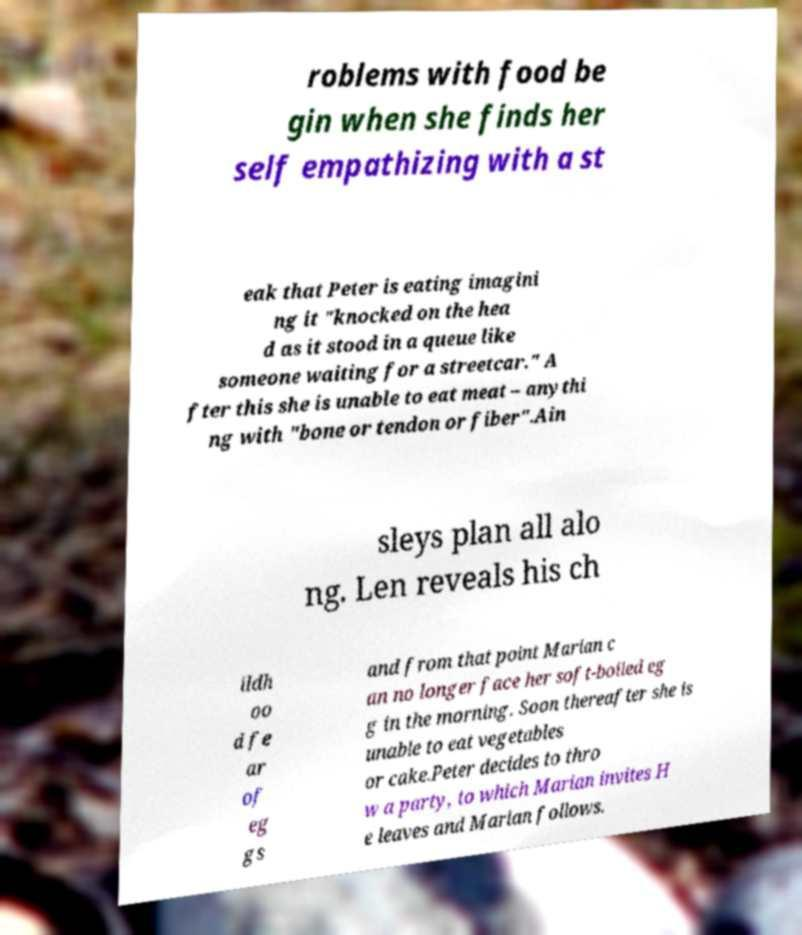For documentation purposes, I need the text within this image transcribed. Could you provide that? roblems with food be gin when she finds her self empathizing with a st eak that Peter is eating imagini ng it "knocked on the hea d as it stood in a queue like someone waiting for a streetcar." A fter this she is unable to eat meat – anythi ng with "bone or tendon or fiber".Ain sleys plan all alo ng. Len reveals his ch ildh oo d fe ar of eg gs and from that point Marian c an no longer face her soft-boiled eg g in the morning. Soon thereafter she is unable to eat vegetables or cake.Peter decides to thro w a party, to which Marian invites H e leaves and Marian follows. 